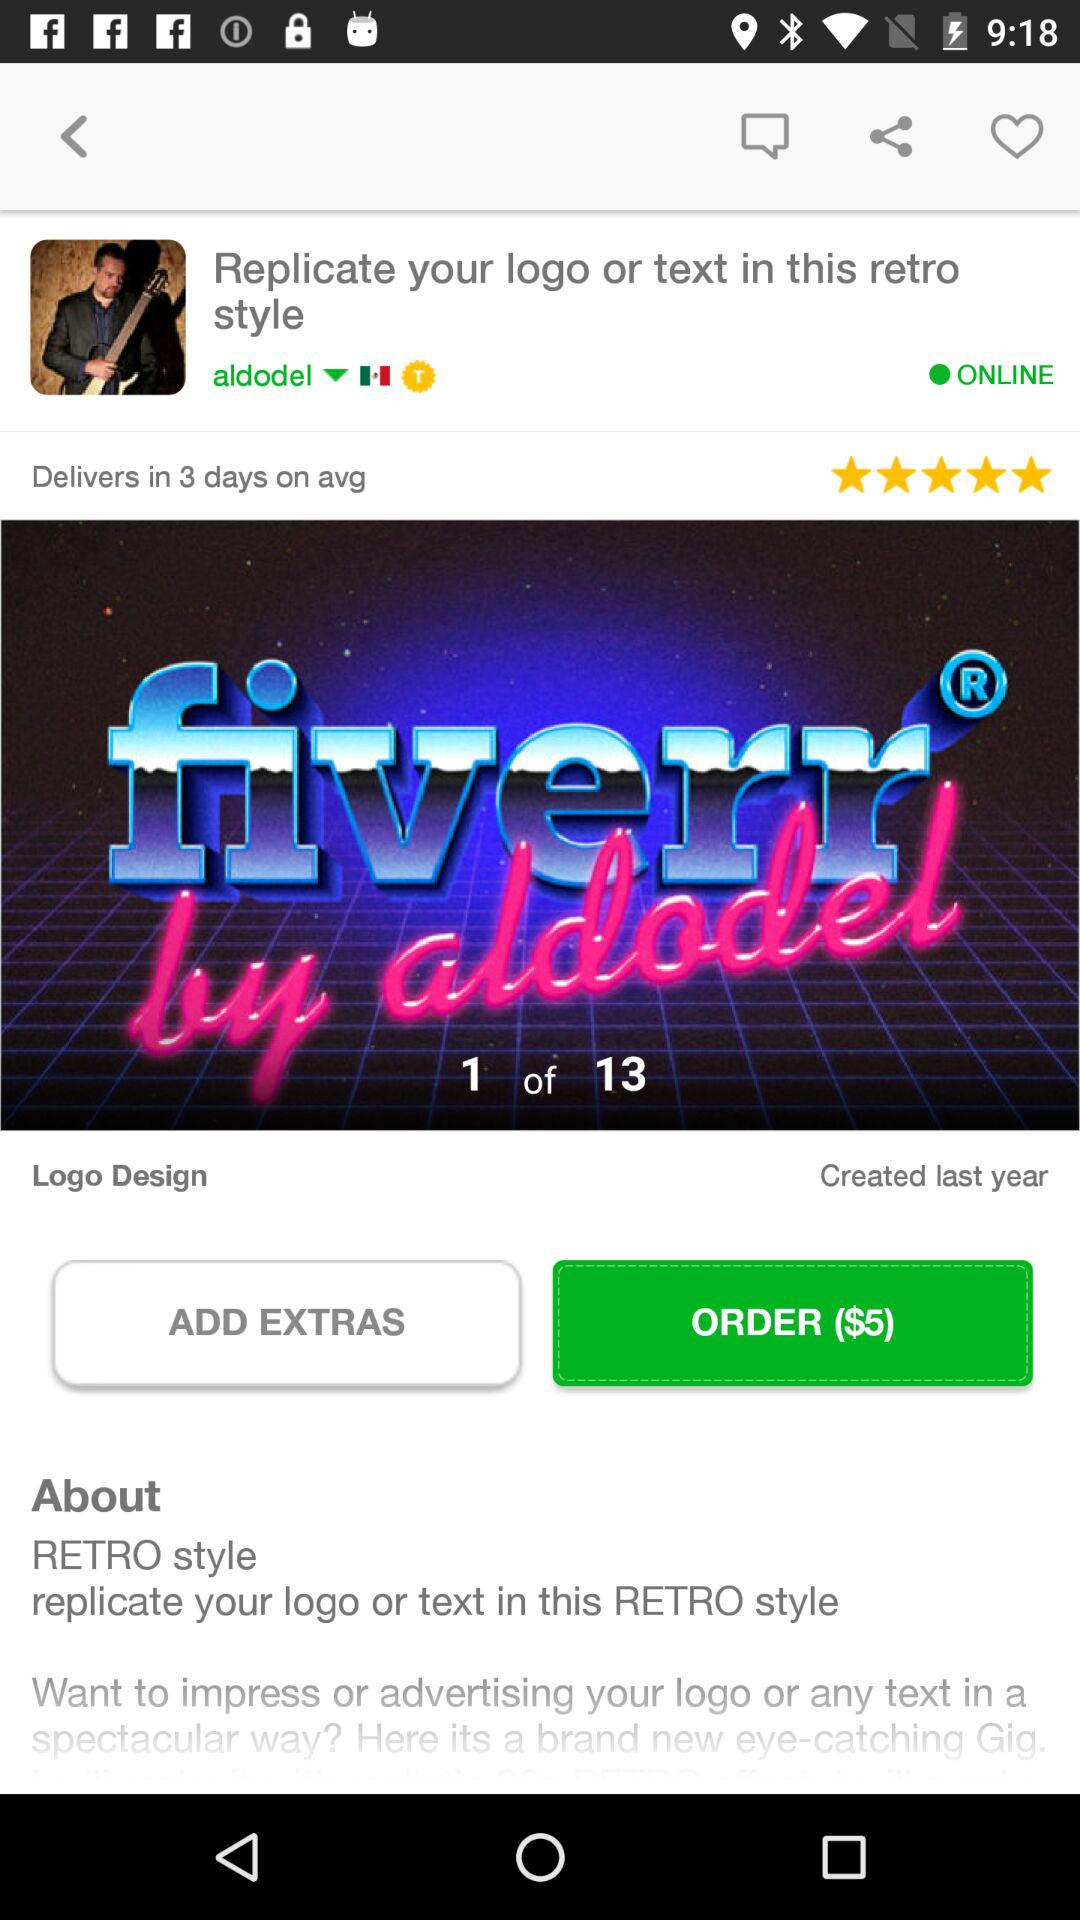How many logo designs are there? There are 13 logo designs. 